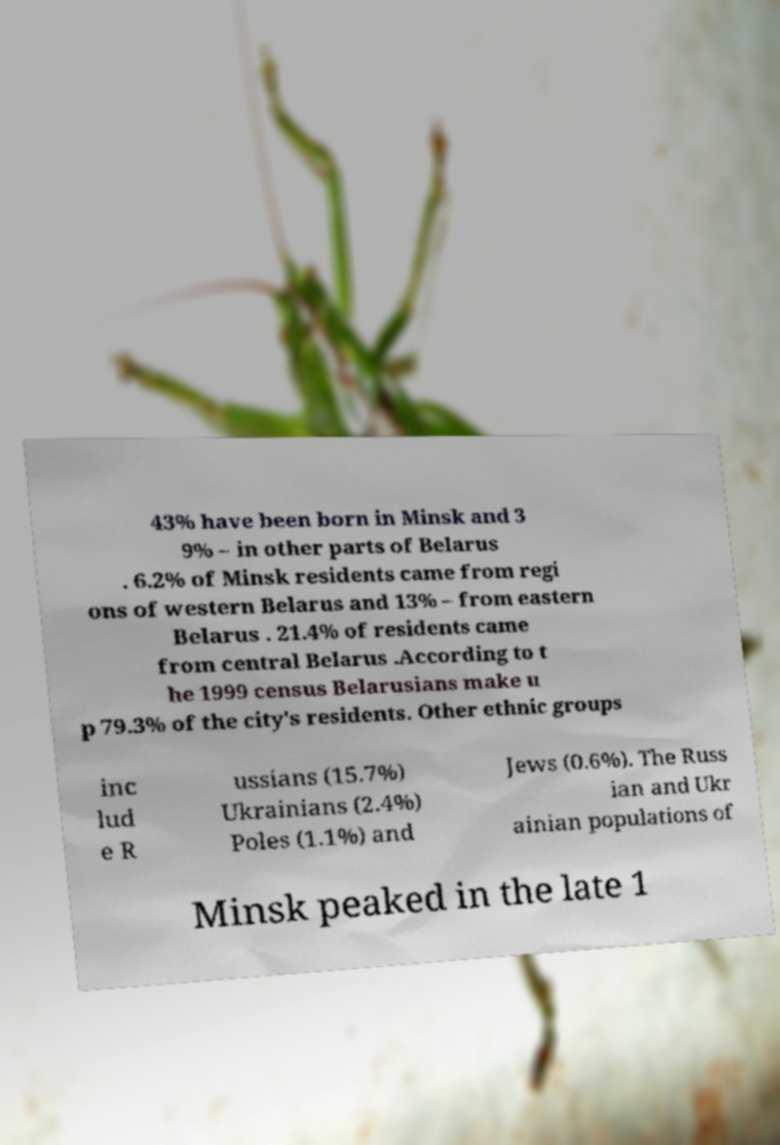Please read and relay the text visible in this image. What does it say? 43% have been born in Minsk and 3 9% – in other parts of Belarus . 6.2% of Minsk residents came from regi ons of western Belarus and 13% – from eastern Belarus . 21.4% of residents came from central Belarus .According to t he 1999 census Belarusians make u p 79.3% of the city's residents. Other ethnic groups inc lud e R ussians (15.7%) Ukrainians (2.4%) Poles (1.1%) and Jews (0.6%). The Russ ian and Ukr ainian populations of Minsk peaked in the late 1 